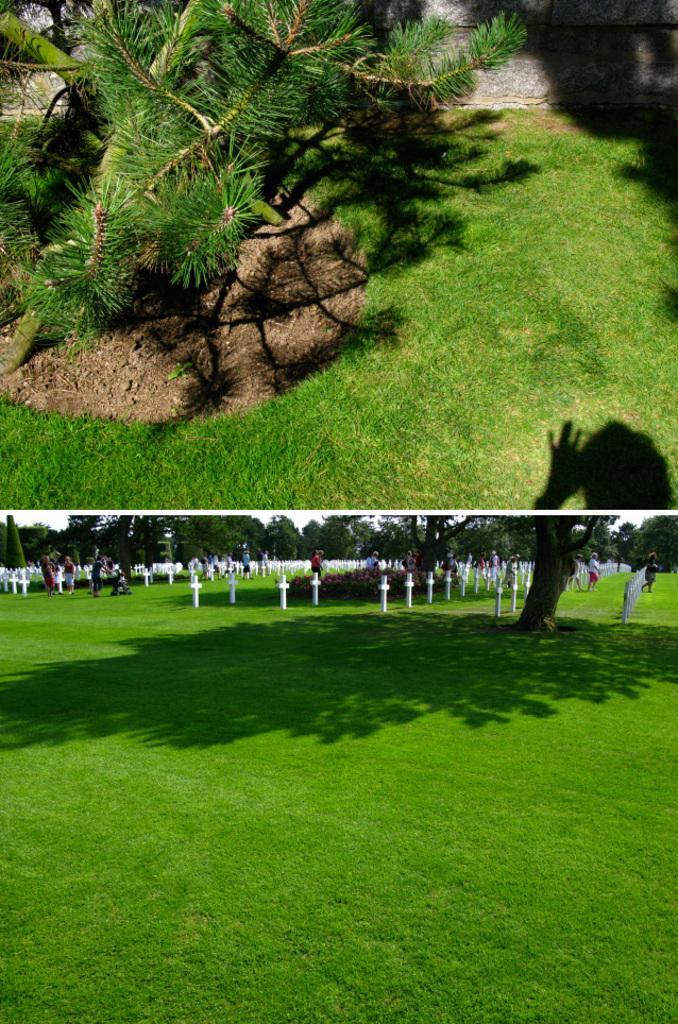Can you describe this image briefly? In this picture I can see the collage images and on the bottom image I can see the grass, number of trees, people and the crosses. On the top image I can see the grass, a plant and the shadows. 